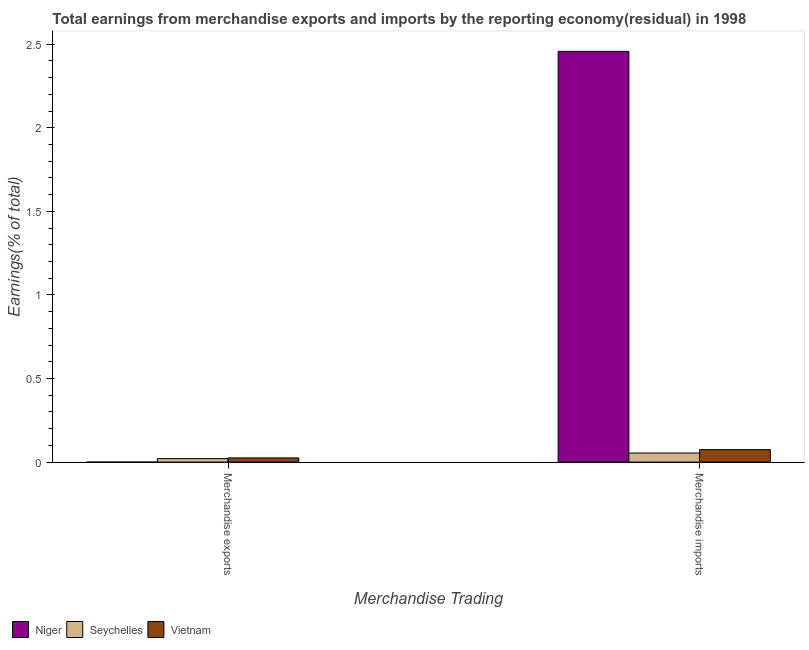How many different coloured bars are there?
Offer a terse response. 3. Are the number of bars per tick equal to the number of legend labels?
Provide a succinct answer. No. Are the number of bars on each tick of the X-axis equal?
Ensure brevity in your answer.  No. How many bars are there on the 1st tick from the right?
Provide a succinct answer. 3. What is the earnings from merchandise exports in Niger?
Offer a terse response. 0. Across all countries, what is the maximum earnings from merchandise exports?
Your response must be concise. 0.03. In which country was the earnings from merchandise imports maximum?
Ensure brevity in your answer.  Niger. What is the total earnings from merchandise exports in the graph?
Keep it short and to the point. 0.05. What is the difference between the earnings from merchandise exports in Vietnam and that in Seychelles?
Your response must be concise. 0. What is the difference between the earnings from merchandise exports in Vietnam and the earnings from merchandise imports in Niger?
Give a very brief answer. -2.43. What is the average earnings from merchandise imports per country?
Your answer should be compact. 0.86. What is the difference between the earnings from merchandise exports and earnings from merchandise imports in Vietnam?
Give a very brief answer. -0.05. What is the ratio of the earnings from merchandise imports in Niger to that in Vietnam?
Your answer should be very brief. 32.84. Is the earnings from merchandise imports in Vietnam less than that in Seychelles?
Offer a terse response. No. Does the graph contain any zero values?
Give a very brief answer. Yes. Where does the legend appear in the graph?
Keep it short and to the point. Bottom left. How many legend labels are there?
Offer a very short reply. 3. How are the legend labels stacked?
Provide a short and direct response. Horizontal. What is the title of the graph?
Offer a terse response. Total earnings from merchandise exports and imports by the reporting economy(residual) in 1998. What is the label or title of the X-axis?
Give a very brief answer. Merchandise Trading. What is the label or title of the Y-axis?
Your response must be concise. Earnings(% of total). What is the Earnings(% of total) of Seychelles in Merchandise exports?
Offer a terse response. 0.02. What is the Earnings(% of total) in Vietnam in Merchandise exports?
Your answer should be very brief. 0.03. What is the Earnings(% of total) of Niger in Merchandise imports?
Give a very brief answer. 2.46. What is the Earnings(% of total) of Seychelles in Merchandise imports?
Offer a terse response. 0.05. What is the Earnings(% of total) of Vietnam in Merchandise imports?
Offer a very short reply. 0.07. Across all Merchandise Trading, what is the maximum Earnings(% of total) in Niger?
Ensure brevity in your answer.  2.46. Across all Merchandise Trading, what is the maximum Earnings(% of total) of Seychelles?
Your answer should be very brief. 0.05. Across all Merchandise Trading, what is the maximum Earnings(% of total) of Vietnam?
Make the answer very short. 0.07. Across all Merchandise Trading, what is the minimum Earnings(% of total) of Niger?
Your answer should be very brief. 0. Across all Merchandise Trading, what is the minimum Earnings(% of total) of Seychelles?
Provide a succinct answer. 0.02. Across all Merchandise Trading, what is the minimum Earnings(% of total) in Vietnam?
Ensure brevity in your answer.  0.03. What is the total Earnings(% of total) of Niger in the graph?
Your answer should be compact. 2.46. What is the total Earnings(% of total) in Seychelles in the graph?
Ensure brevity in your answer.  0.08. What is the total Earnings(% of total) of Vietnam in the graph?
Offer a very short reply. 0.1. What is the difference between the Earnings(% of total) in Seychelles in Merchandise exports and that in Merchandise imports?
Offer a very short reply. -0.03. What is the difference between the Earnings(% of total) in Vietnam in Merchandise exports and that in Merchandise imports?
Keep it short and to the point. -0.05. What is the difference between the Earnings(% of total) of Seychelles in Merchandise exports and the Earnings(% of total) of Vietnam in Merchandise imports?
Ensure brevity in your answer.  -0.05. What is the average Earnings(% of total) of Niger per Merchandise Trading?
Make the answer very short. 1.23. What is the average Earnings(% of total) of Seychelles per Merchandise Trading?
Keep it short and to the point. 0.04. What is the average Earnings(% of total) of Vietnam per Merchandise Trading?
Provide a short and direct response. 0.05. What is the difference between the Earnings(% of total) in Seychelles and Earnings(% of total) in Vietnam in Merchandise exports?
Ensure brevity in your answer.  -0. What is the difference between the Earnings(% of total) of Niger and Earnings(% of total) of Seychelles in Merchandise imports?
Provide a succinct answer. 2.4. What is the difference between the Earnings(% of total) in Niger and Earnings(% of total) in Vietnam in Merchandise imports?
Provide a succinct answer. 2.38. What is the difference between the Earnings(% of total) of Seychelles and Earnings(% of total) of Vietnam in Merchandise imports?
Provide a succinct answer. -0.02. What is the ratio of the Earnings(% of total) in Seychelles in Merchandise exports to that in Merchandise imports?
Your answer should be very brief. 0.39. What is the ratio of the Earnings(% of total) in Vietnam in Merchandise exports to that in Merchandise imports?
Keep it short and to the point. 0.34. What is the difference between the highest and the second highest Earnings(% of total) in Seychelles?
Your answer should be very brief. 0.03. What is the difference between the highest and the second highest Earnings(% of total) of Vietnam?
Your answer should be compact. 0.05. What is the difference between the highest and the lowest Earnings(% of total) of Niger?
Offer a terse response. 2.46. What is the difference between the highest and the lowest Earnings(% of total) in Seychelles?
Provide a succinct answer. 0.03. What is the difference between the highest and the lowest Earnings(% of total) of Vietnam?
Offer a very short reply. 0.05. 